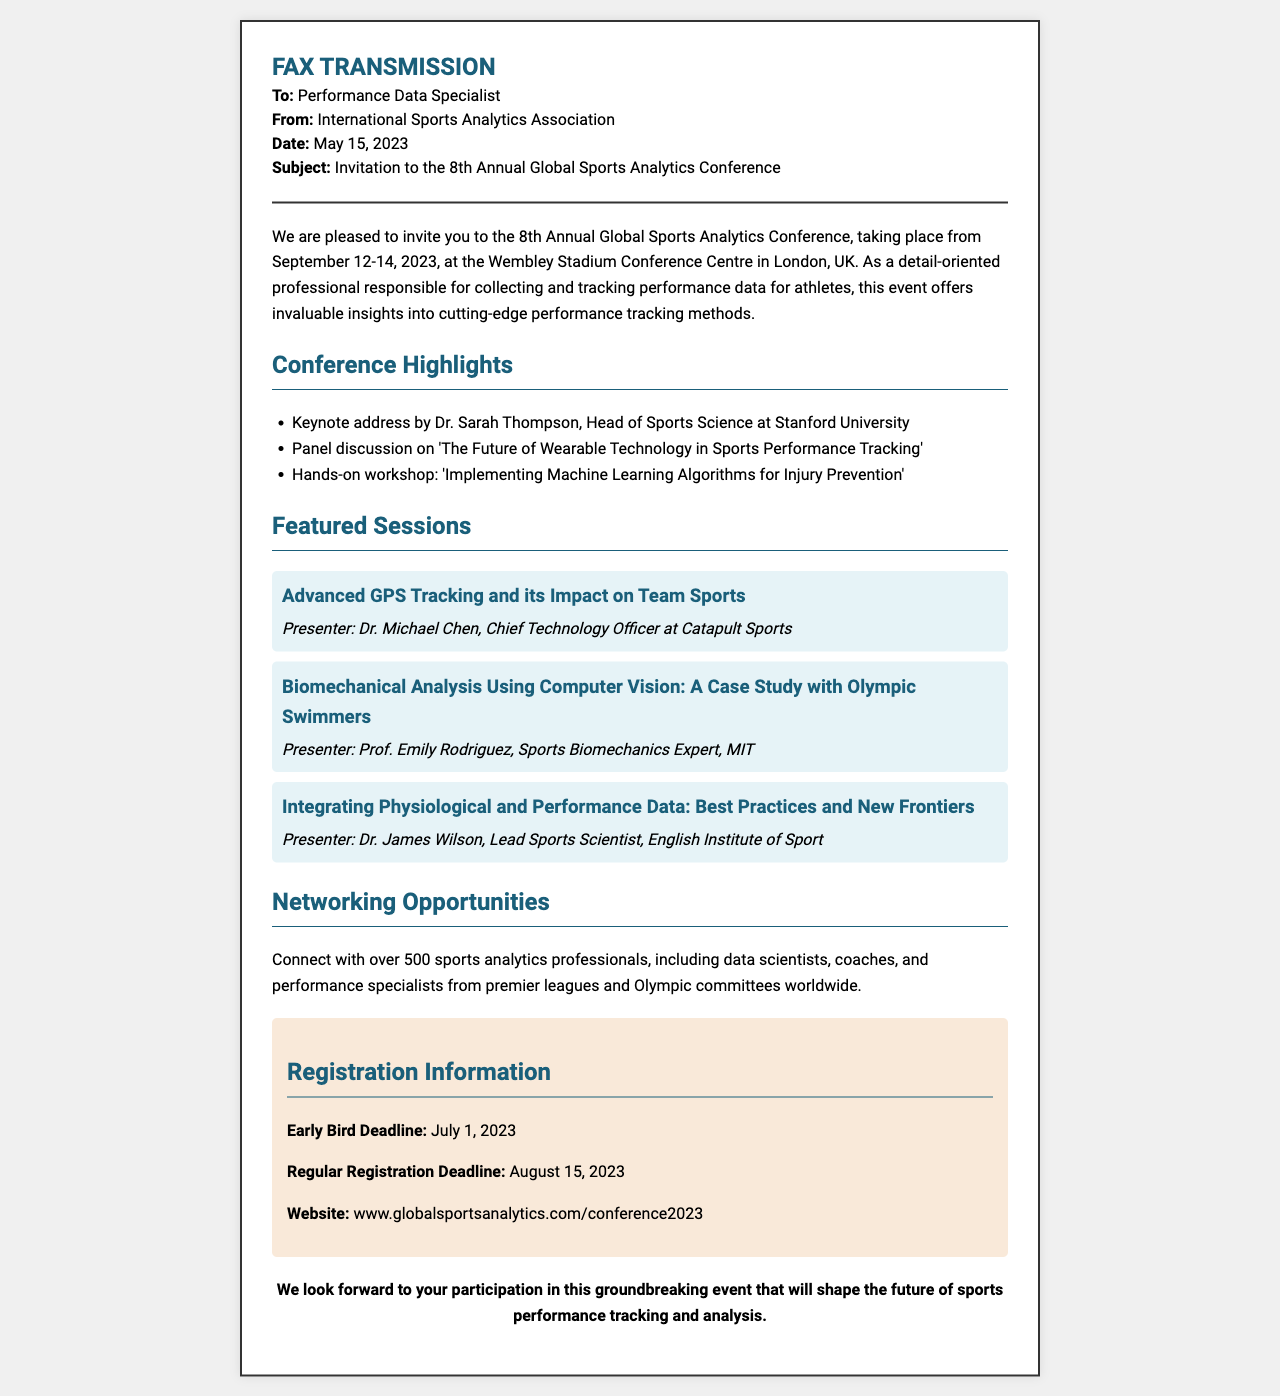what are the conference dates? The document specifies the conference will take place from September 12-14, 2023.
Answer: September 12-14, 2023 who is the keynote speaker? The keynote address will be given by Dr. Sarah Thompson.
Answer: Dr. Sarah Thompson what is the early bird registration deadline? The document states the early bird registration deadline is July 1, 2023.
Answer: July 1, 2023 which session focuses on wearable technology? The panel discussion mentioned in the conference highlights addresses 'The Future of Wearable Technology in Sports Performance Tracking'.
Answer: The Future of Wearable Technology in Sports Performance Tracking how many sports analytics professionals will attend? The document indicates there will be over 500 sports analytics professionals attending the conference.
Answer: 500 who presents on biomechanical analysis? The featured session on biomechanical analysis is presented by Prof. Emily Rodriguez.
Answer: Prof. Emily Rodriguez what is the website for registration? The registration information includes the website www.globalsportsanalytics.com/conference2023.
Answer: www.globalsportsanalytics.com/conference2023 what type of event is this document promoting? The fax invitation is promoting an annual global sports analytics conference.
Answer: annual global sports analytics conference 